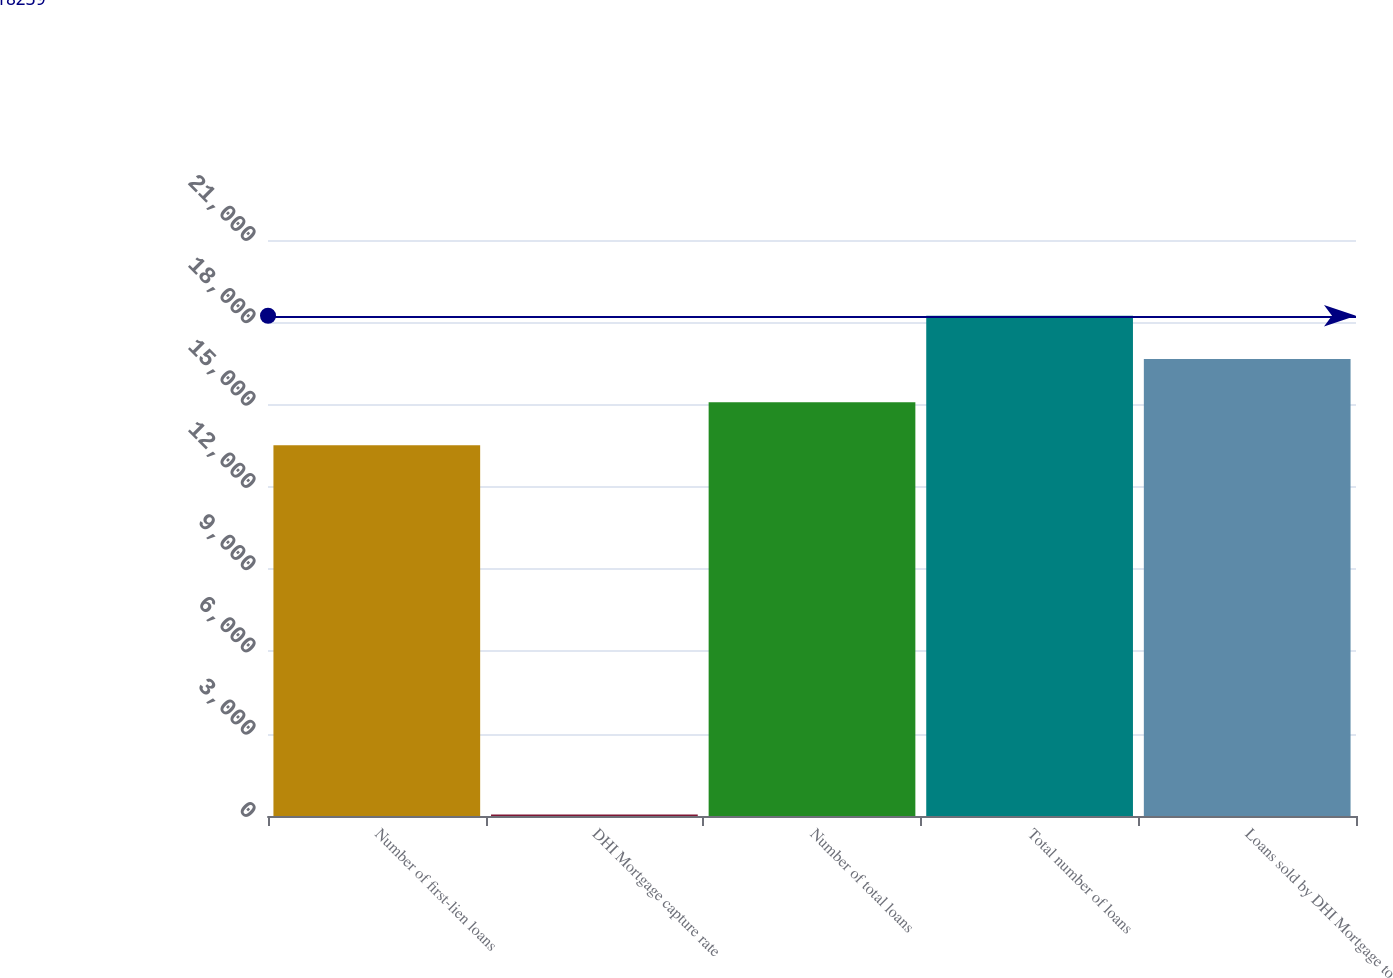<chart> <loc_0><loc_0><loc_500><loc_500><bar_chart><fcel>Number of first-lien loans<fcel>DHI Mortgage capture rate<fcel>Number of total loans<fcel>Total number of loans<fcel>Loans sold by DHI Mortgage to<nl><fcel>13514<fcel>56<fcel>15089<fcel>18239<fcel>16664<nl></chart> 